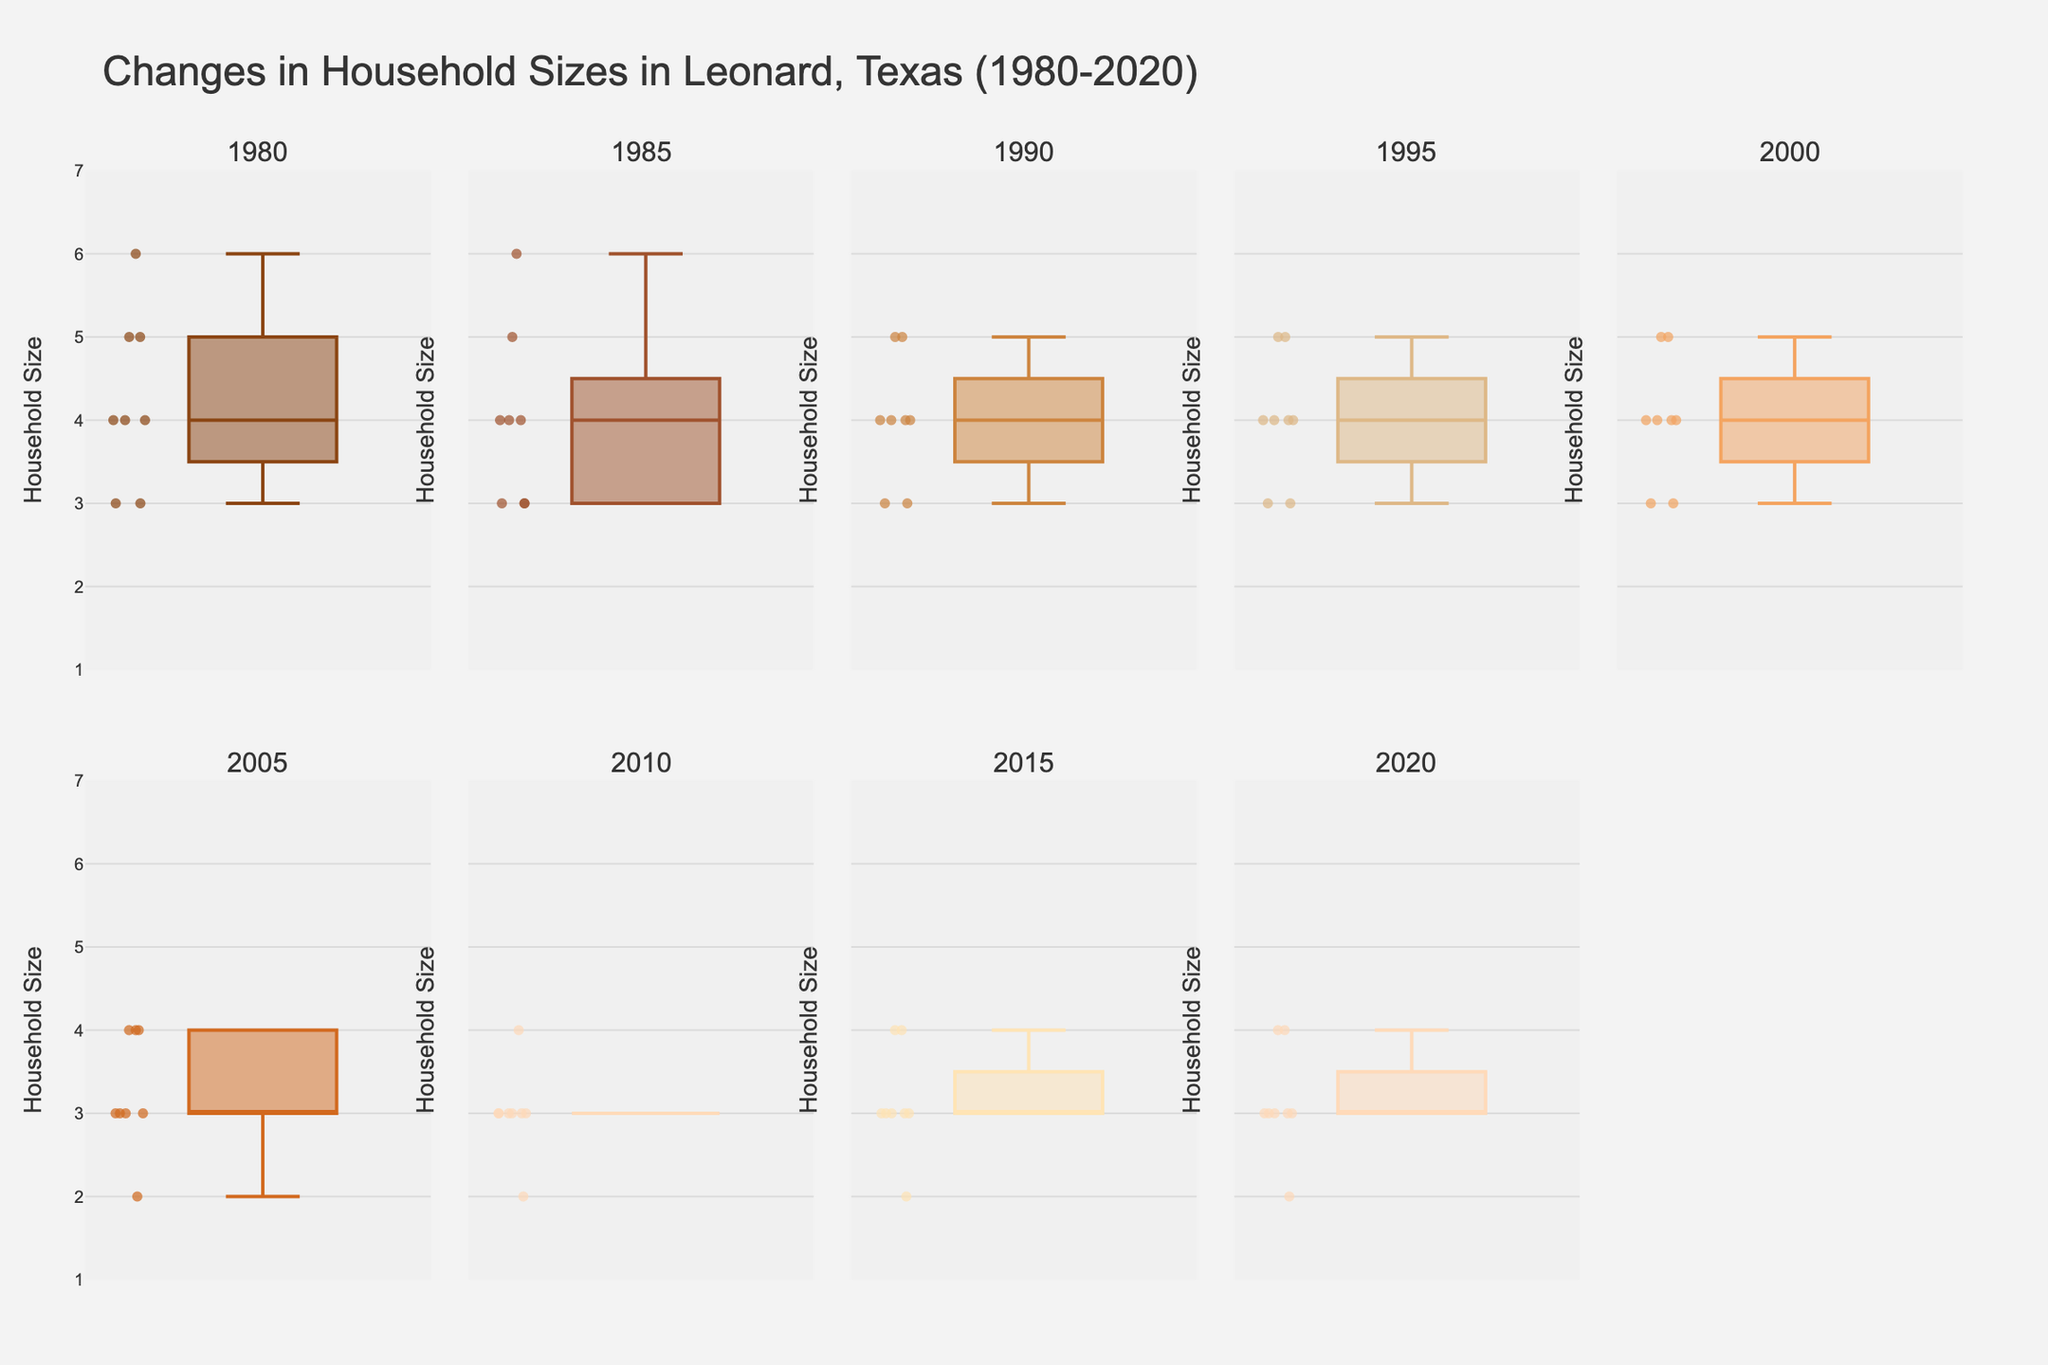What is the title of the figure? The title of the figure is usually placed at the top and provides a summary of what the data represents. In this case, it reads "Changes in Household Sizes in Leonard, Texas (1980-2020)."
Answer: Changes in Household Sizes in Leonard, Texas (1980-2020) What is the range of the y-axis in the figure? The y-axis range can be identified by looking at the minimum and maximum values marked on the axis. Here, it ranges from 1 to 7.
Answer: 1 to 7 How many subplots are there in the figure? The number of subplots can be counted by observing the separate box plots, each representing a different year. There are a total of 10 subplots in this figure.
Answer: 10 Which year has the highest median household size? To find the year with the highest median household size, look at the central line in each box plot. The year 1980 has the highest median as its line is higher than those of the other years.
Answer: 1980 What is the median household size for the year 2005? The median is represented by the line in the middle of the box plot for the year 2005. Here, it appears to be 3.
Answer: 3 How does the spread of household sizes change from 1980 to 2020? Compare the interquartile range (IQR, the box itself) from 1980 to 2020. In 1980, the spread is wider, and it narrows down by 2020, indicating decreased variability.
Answer: Decreased variability Which year shows the smallest range in household sizes? The range can be seen from the difference between the upper and lower whisker ends. The year 2020 shows one of the smallest ranges.
Answer: 2020 Is there any year that has a household size of 6? If yes, which one? Check the maximum points each year's box plot reaches; only 1980 and 1985 appear to have household sizes of 6.
Answer: 1980, 1985 How does the household size in 1980 compare to 2015? Compare the box plots of 1980 and 2015. In 1980, the household sizes are generally larger, showing higher quartiles and medians compared to the box plot of 2015.
Answer: Higher in 1980 Was there a year where the household size consistently stayed below 5? Check the upper whisker end for each year. From 2005 onwards, the household sizes consistently stayed below 5.
Answer: From 2005 onward 